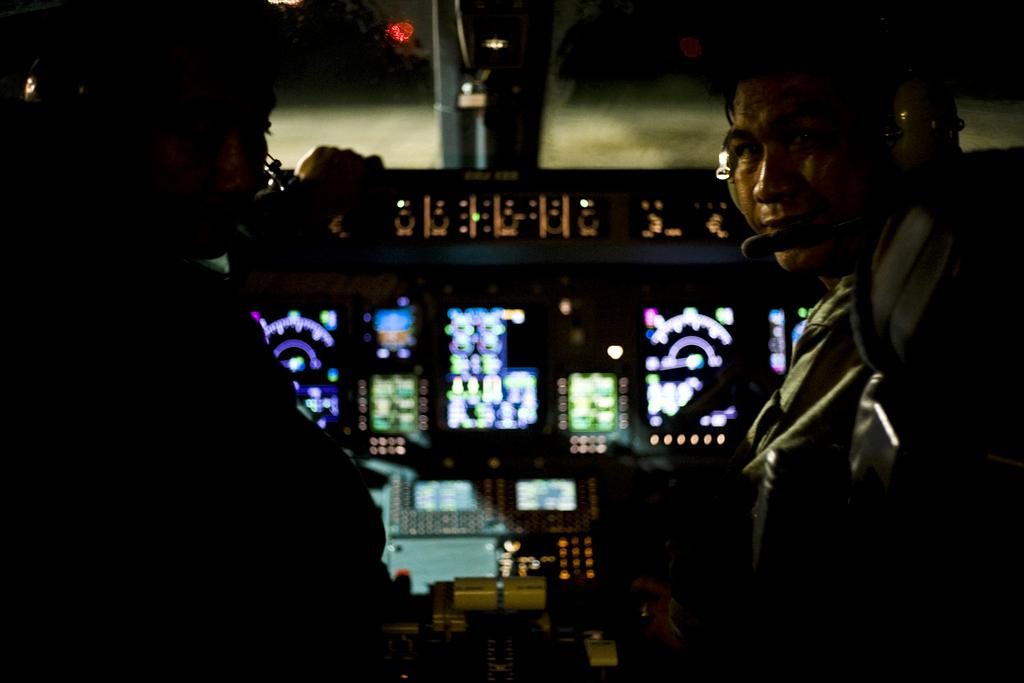Who or what is present in the image? There are people in the image. What else can be seen in the image besides the people? There is equipment and a wall in the image. Can you describe the lighting conditions in the image? There is light in the image. What type of guide or example is being provided by the notebook in the image? There is no notebook present in the image, so no guide or example can be provided by a notebook. 